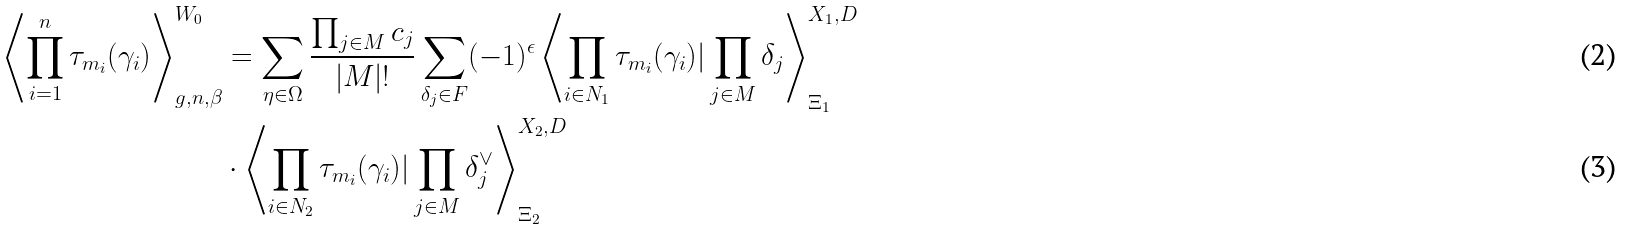<formula> <loc_0><loc_0><loc_500><loc_500>\left \langle \prod _ { i = 1 } ^ { n } { \tau _ { m _ { i } } ( \gamma _ { i } ) } \right \rangle _ { g , n , \beta } ^ { W _ { 0 } } & = \sum _ { \eta \in \Omega } \frac { \prod _ { j \in M } c _ { j } } { | M | ! } \sum _ { \delta _ { j } \in F } ( - 1 ) ^ { \epsilon } \left \langle \prod _ { i \in N _ { 1 } } \tau _ { m _ { i } } ( \gamma _ { i } ) | \prod _ { j \in M } \delta _ { j } \right \rangle _ { \Xi _ { 1 } } ^ { X _ { 1 } , D } \\ & \cdot \left \langle \prod _ { i \in N _ { 2 } } \tau _ { m _ { i } } ( \gamma _ { i } ) | \prod _ { j \in M } \delta _ { j } ^ { \vee } \right \rangle _ { \Xi _ { 2 } } ^ { X _ { 2 } , D }</formula> 